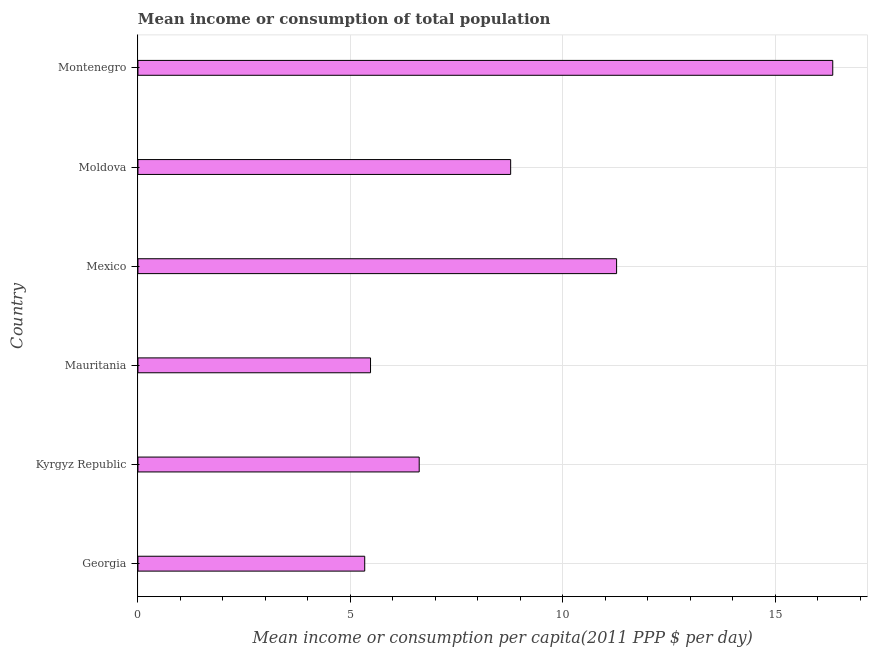Does the graph contain any zero values?
Your answer should be compact. No. Does the graph contain grids?
Your response must be concise. Yes. What is the title of the graph?
Your response must be concise. Mean income or consumption of total population. What is the label or title of the X-axis?
Make the answer very short. Mean income or consumption per capita(2011 PPP $ per day). What is the mean income or consumption in Georgia?
Give a very brief answer. 5.34. Across all countries, what is the maximum mean income or consumption?
Offer a terse response. 16.35. Across all countries, what is the minimum mean income or consumption?
Offer a very short reply. 5.34. In which country was the mean income or consumption maximum?
Ensure brevity in your answer.  Montenegro. In which country was the mean income or consumption minimum?
Your answer should be very brief. Georgia. What is the sum of the mean income or consumption?
Keep it short and to the point. 53.83. What is the difference between the mean income or consumption in Georgia and Mauritania?
Your answer should be compact. -0.14. What is the average mean income or consumption per country?
Keep it short and to the point. 8.97. What is the median mean income or consumption?
Keep it short and to the point. 7.7. In how many countries, is the mean income or consumption greater than 1 $?
Provide a short and direct response. 6. What is the ratio of the mean income or consumption in Kyrgyz Republic to that in Montenegro?
Provide a succinct answer. 0.41. Is the mean income or consumption in Georgia less than that in Mauritania?
Keep it short and to the point. Yes. Is the difference between the mean income or consumption in Moldova and Montenegro greater than the difference between any two countries?
Ensure brevity in your answer.  No. What is the difference between the highest and the second highest mean income or consumption?
Your answer should be compact. 5.09. What is the difference between the highest and the lowest mean income or consumption?
Give a very brief answer. 11.02. How many bars are there?
Provide a succinct answer. 6. Are all the bars in the graph horizontal?
Your response must be concise. Yes. What is the Mean income or consumption per capita(2011 PPP $ per day) of Georgia?
Make the answer very short. 5.34. What is the Mean income or consumption per capita(2011 PPP $ per day) in Kyrgyz Republic?
Keep it short and to the point. 6.62. What is the Mean income or consumption per capita(2011 PPP $ per day) of Mauritania?
Your answer should be very brief. 5.47. What is the Mean income or consumption per capita(2011 PPP $ per day) in Mexico?
Your response must be concise. 11.27. What is the Mean income or consumption per capita(2011 PPP $ per day) in Moldova?
Provide a short and direct response. 8.77. What is the Mean income or consumption per capita(2011 PPP $ per day) of Montenegro?
Provide a succinct answer. 16.35. What is the difference between the Mean income or consumption per capita(2011 PPP $ per day) in Georgia and Kyrgyz Republic?
Your answer should be compact. -1.28. What is the difference between the Mean income or consumption per capita(2011 PPP $ per day) in Georgia and Mauritania?
Keep it short and to the point. -0.14. What is the difference between the Mean income or consumption per capita(2011 PPP $ per day) in Georgia and Mexico?
Your answer should be compact. -5.93. What is the difference between the Mean income or consumption per capita(2011 PPP $ per day) in Georgia and Moldova?
Provide a succinct answer. -3.44. What is the difference between the Mean income or consumption per capita(2011 PPP $ per day) in Georgia and Montenegro?
Ensure brevity in your answer.  -11.02. What is the difference between the Mean income or consumption per capita(2011 PPP $ per day) in Kyrgyz Republic and Mauritania?
Keep it short and to the point. 1.15. What is the difference between the Mean income or consumption per capita(2011 PPP $ per day) in Kyrgyz Republic and Mexico?
Offer a very short reply. -4.65. What is the difference between the Mean income or consumption per capita(2011 PPP $ per day) in Kyrgyz Republic and Moldova?
Provide a short and direct response. -2.15. What is the difference between the Mean income or consumption per capita(2011 PPP $ per day) in Kyrgyz Republic and Montenegro?
Give a very brief answer. -9.73. What is the difference between the Mean income or consumption per capita(2011 PPP $ per day) in Mauritania and Mexico?
Provide a succinct answer. -5.79. What is the difference between the Mean income or consumption per capita(2011 PPP $ per day) in Mauritania and Moldova?
Make the answer very short. -3.3. What is the difference between the Mean income or consumption per capita(2011 PPP $ per day) in Mauritania and Montenegro?
Your answer should be very brief. -10.88. What is the difference between the Mean income or consumption per capita(2011 PPP $ per day) in Mexico and Moldova?
Offer a very short reply. 2.49. What is the difference between the Mean income or consumption per capita(2011 PPP $ per day) in Mexico and Montenegro?
Provide a short and direct response. -5.09. What is the difference between the Mean income or consumption per capita(2011 PPP $ per day) in Moldova and Montenegro?
Provide a short and direct response. -7.58. What is the ratio of the Mean income or consumption per capita(2011 PPP $ per day) in Georgia to that in Kyrgyz Republic?
Offer a very short reply. 0.81. What is the ratio of the Mean income or consumption per capita(2011 PPP $ per day) in Georgia to that in Mauritania?
Your answer should be compact. 0.97. What is the ratio of the Mean income or consumption per capita(2011 PPP $ per day) in Georgia to that in Mexico?
Make the answer very short. 0.47. What is the ratio of the Mean income or consumption per capita(2011 PPP $ per day) in Georgia to that in Moldova?
Provide a short and direct response. 0.61. What is the ratio of the Mean income or consumption per capita(2011 PPP $ per day) in Georgia to that in Montenegro?
Provide a short and direct response. 0.33. What is the ratio of the Mean income or consumption per capita(2011 PPP $ per day) in Kyrgyz Republic to that in Mauritania?
Keep it short and to the point. 1.21. What is the ratio of the Mean income or consumption per capita(2011 PPP $ per day) in Kyrgyz Republic to that in Mexico?
Provide a succinct answer. 0.59. What is the ratio of the Mean income or consumption per capita(2011 PPP $ per day) in Kyrgyz Republic to that in Moldova?
Your answer should be compact. 0.76. What is the ratio of the Mean income or consumption per capita(2011 PPP $ per day) in Kyrgyz Republic to that in Montenegro?
Your answer should be very brief. 0.41. What is the ratio of the Mean income or consumption per capita(2011 PPP $ per day) in Mauritania to that in Mexico?
Give a very brief answer. 0.49. What is the ratio of the Mean income or consumption per capita(2011 PPP $ per day) in Mauritania to that in Moldova?
Provide a short and direct response. 0.62. What is the ratio of the Mean income or consumption per capita(2011 PPP $ per day) in Mauritania to that in Montenegro?
Your answer should be very brief. 0.34. What is the ratio of the Mean income or consumption per capita(2011 PPP $ per day) in Mexico to that in Moldova?
Offer a very short reply. 1.28. What is the ratio of the Mean income or consumption per capita(2011 PPP $ per day) in Mexico to that in Montenegro?
Your answer should be very brief. 0.69. What is the ratio of the Mean income or consumption per capita(2011 PPP $ per day) in Moldova to that in Montenegro?
Your answer should be compact. 0.54. 